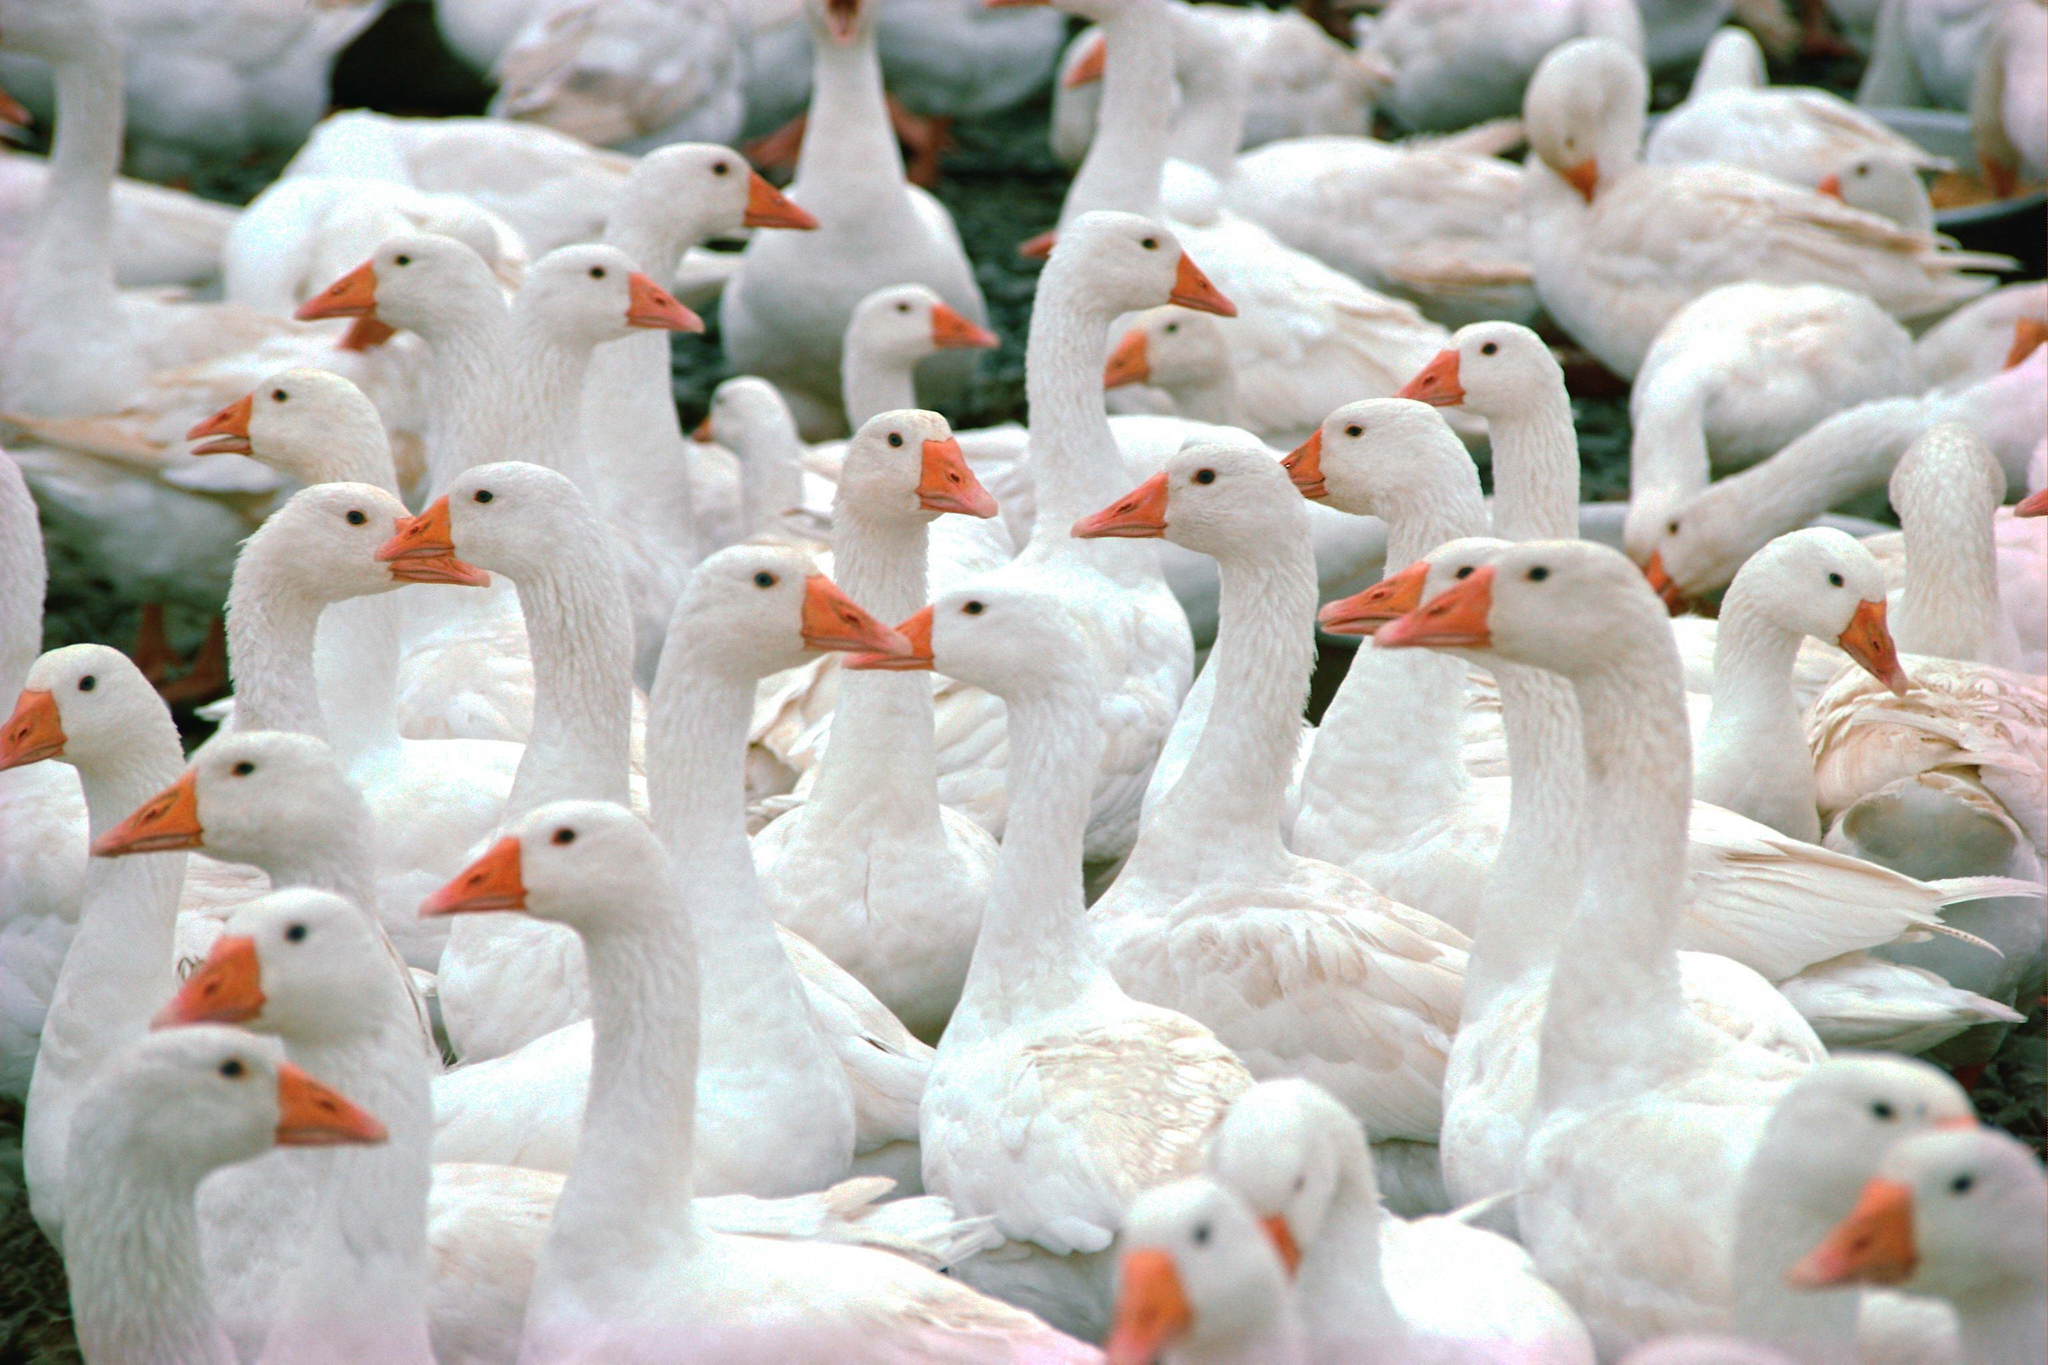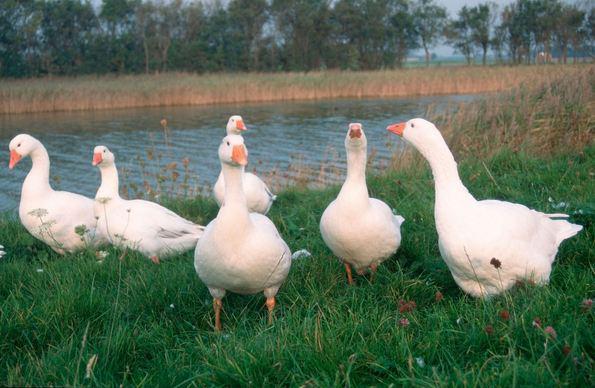The first image is the image on the left, the second image is the image on the right. Analyze the images presented: Is the assertion "One of the images shows exactly 6 geese." valid? Answer yes or no. Yes. The first image is the image on the left, the second image is the image on the right. For the images shown, is this caption "At least one image shows no less than 20 white fowl." true? Answer yes or no. Yes. 